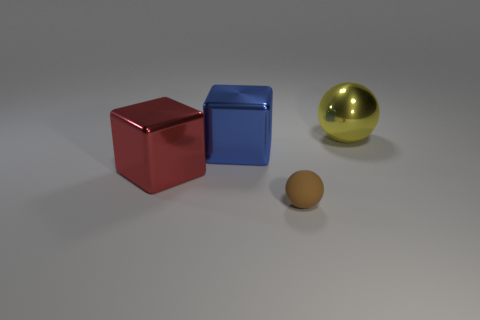How many big metal things are on the right side of the blue metallic thing?
Your answer should be very brief. 1. How many things are gray metallic cylinders or big blue blocks?
Give a very brief answer. 1. The object that is to the right of the blue object and behind the small thing has what shape?
Offer a terse response. Sphere. How many small brown matte spheres are there?
Provide a succinct answer. 1. What color is the block that is the same material as the large blue object?
Make the answer very short. Red. Is the number of yellow things greater than the number of big objects?
Offer a very short reply. No. What size is the thing that is both to the left of the brown object and to the right of the red shiny object?
Make the answer very short. Large. Is the number of brown rubber objects on the left side of the small matte thing the same as the number of tiny metal cubes?
Your answer should be compact. Yes. Is the size of the metallic ball the same as the blue shiny object?
Your answer should be very brief. Yes. There is a thing that is on the right side of the large blue block and behind the tiny ball; what is its color?
Give a very brief answer. Yellow. 